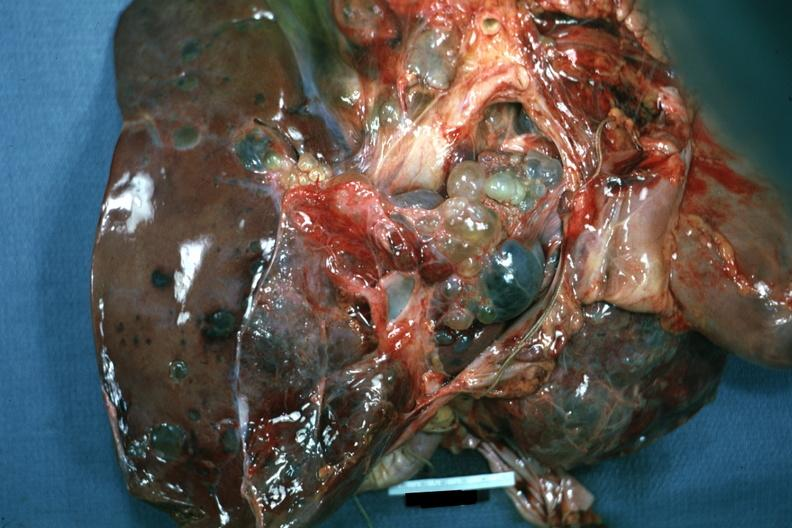how is case of polycystic disease lesions seen from?
Answer the question using a single word or phrase. External 